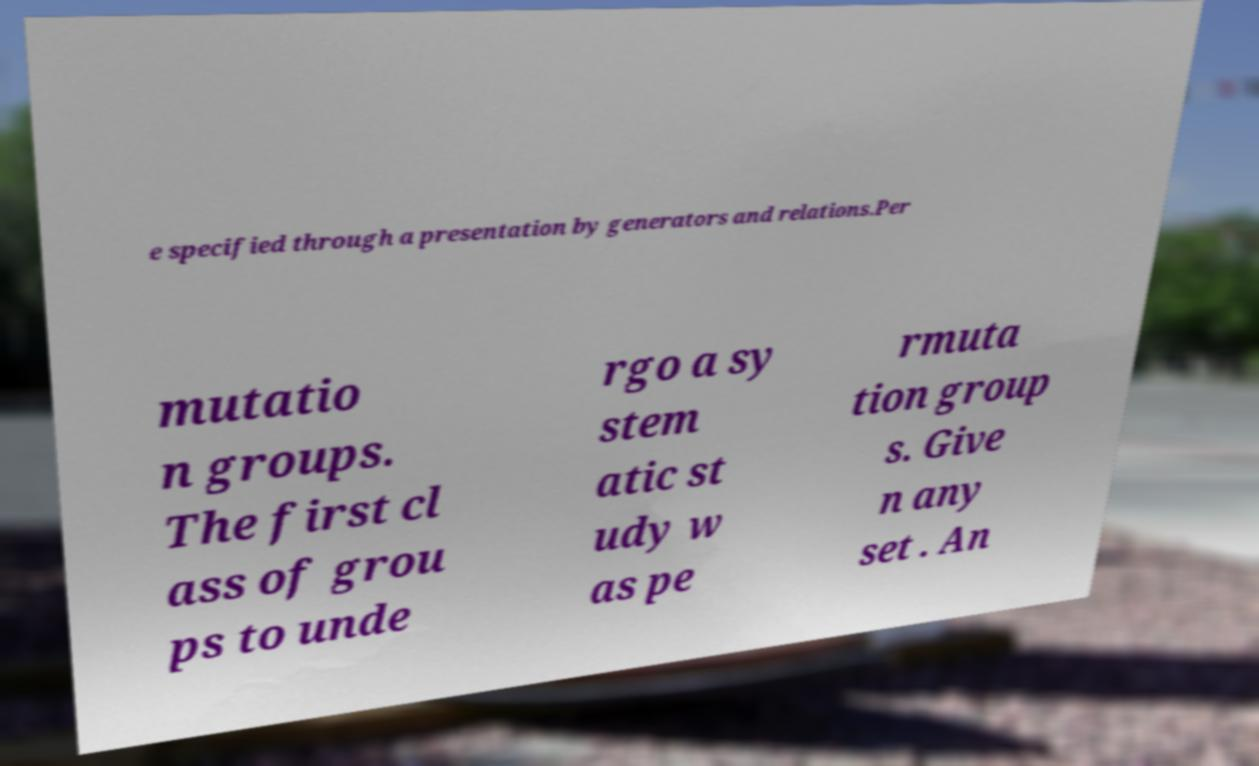Please read and relay the text visible in this image. What does it say? e specified through a presentation by generators and relations.Per mutatio n groups. The first cl ass of grou ps to unde rgo a sy stem atic st udy w as pe rmuta tion group s. Give n any set . An 